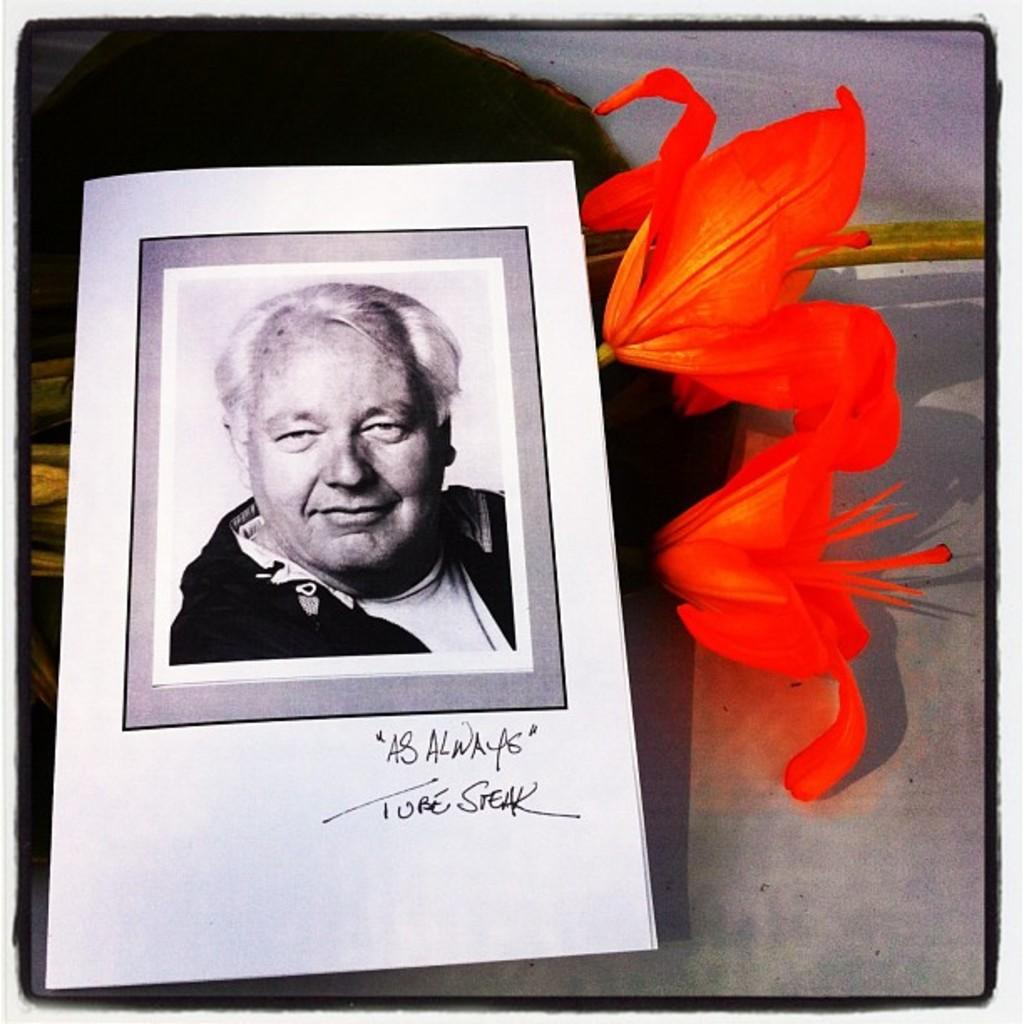What is present on the paper in the image? There is a paper in the image, and it contains an image of a man. What other objects or elements can be seen in the image? There are flowers visible in the image. What type of plant is the father holding in the image? There is no father or plant present in the image; it features a paper with an image of a man and flowers. 